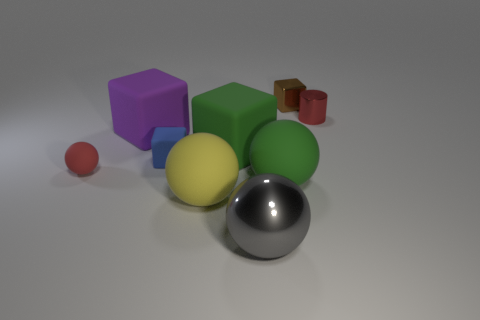There is a small block that is behind the small metal cylinder; how many small blue objects are behind it?
Make the answer very short. 0. There is a thing that is in front of the yellow rubber sphere; does it have the same shape as the shiny object that is behind the tiny red cylinder?
Make the answer very short. No. The thing that is the same color as the tiny ball is what shape?
Ensure brevity in your answer.  Cylinder. Are there any big cyan cubes that have the same material as the red cylinder?
Your answer should be very brief. No. How many metallic things are big yellow cylinders or yellow balls?
Give a very brief answer. 0. What shape is the small red thing to the right of the large green thing that is on the left side of the large green sphere?
Your response must be concise. Cylinder. Is the number of purple matte things that are in front of the purple object less than the number of large purple rubber spheres?
Offer a very short reply. No. The purple thing has what shape?
Offer a terse response. Cube. There is a red thing in front of the tiny blue object; what size is it?
Provide a short and direct response. Small. There is a matte sphere that is the same size as the blue block; what is its color?
Give a very brief answer. Red. 